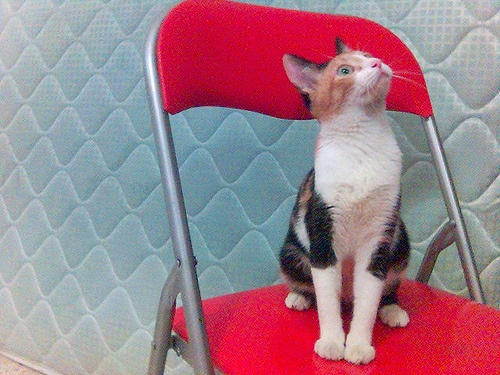Describe the objects in this image and their specific colors. I can see chair in lightgray, gray, and brown tones, bed in lightgray and darkgray tones, and cat in lightgray, darkgray, and black tones in this image. 